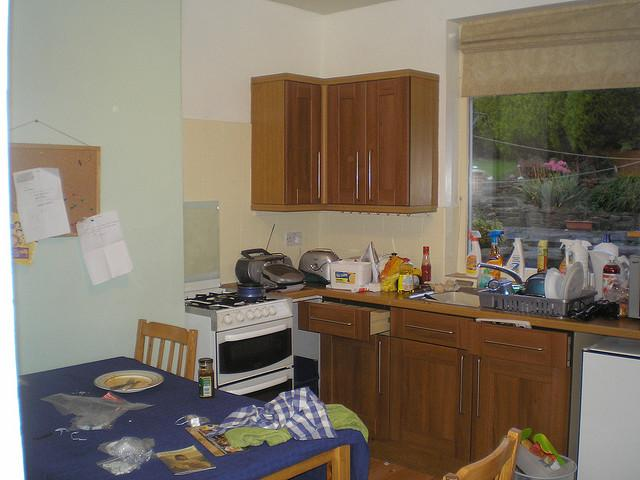What is the object with the metal rod on it? radio 